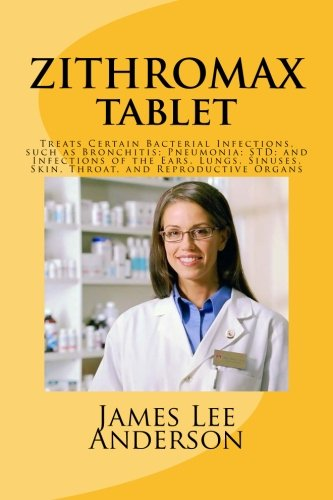Who is the author of this book? The cover of the book attributes authorship to James Lee Anderson, though without additional verification, this information should be taken as presented on the visual medium. 